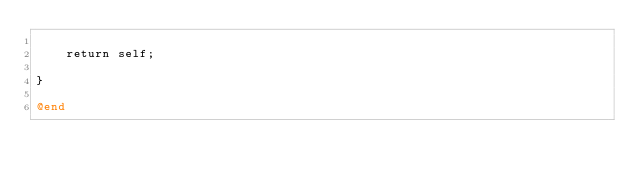Convert code to text. <code><loc_0><loc_0><loc_500><loc_500><_ObjectiveC_>    
    return self;
    
}

@end
</code> 